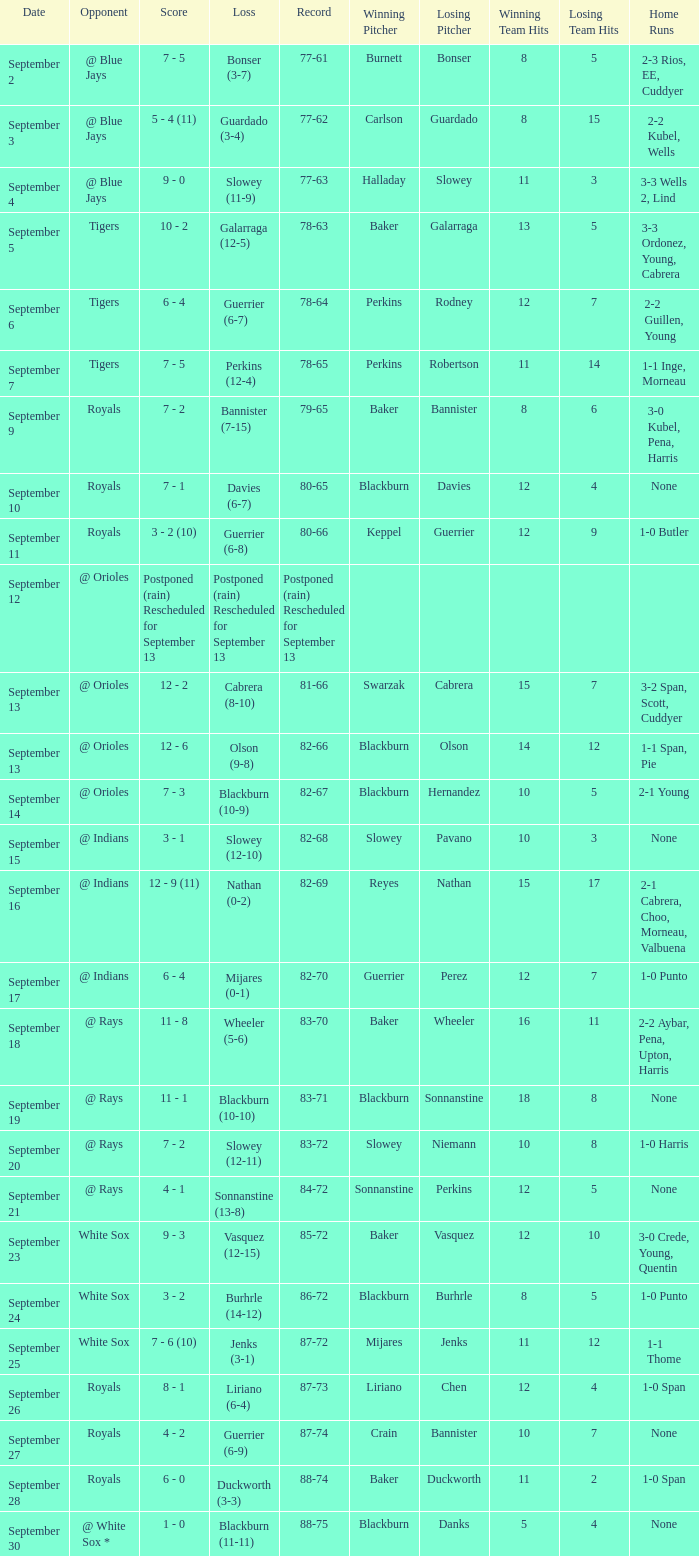What opponnent has a record of 82-68? @ Indians. 